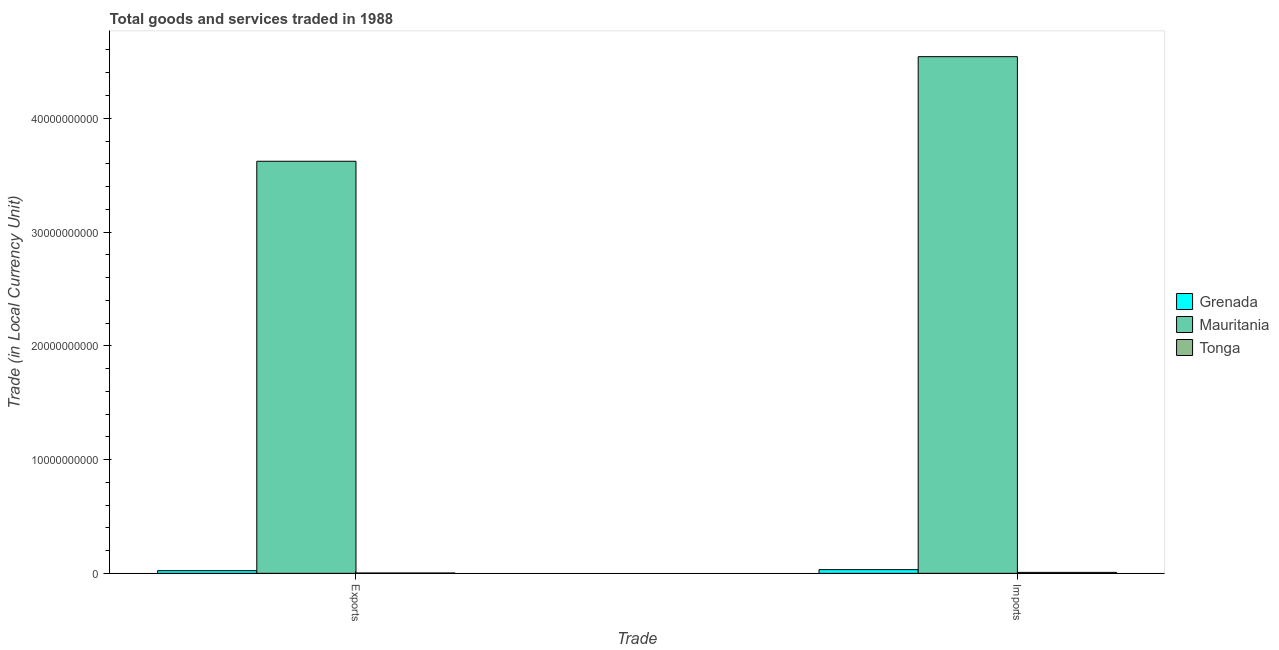How many bars are there on the 1st tick from the left?
Keep it short and to the point. 3. What is the label of the 2nd group of bars from the left?
Ensure brevity in your answer.  Imports. What is the export of goods and services in Tonga?
Offer a very short reply. 2.84e+07. Across all countries, what is the maximum imports of goods and services?
Your answer should be very brief. 4.54e+1. Across all countries, what is the minimum export of goods and services?
Ensure brevity in your answer.  2.84e+07. In which country was the export of goods and services maximum?
Provide a short and direct response. Mauritania. In which country was the imports of goods and services minimum?
Provide a succinct answer. Tonga. What is the total imports of goods and services in the graph?
Keep it short and to the point. 4.58e+1. What is the difference between the export of goods and services in Mauritania and that in Grenada?
Offer a very short reply. 3.60e+1. What is the difference between the imports of goods and services in Tonga and the export of goods and services in Grenada?
Provide a succinct answer. -1.51e+08. What is the average imports of goods and services per country?
Your response must be concise. 1.53e+1. What is the difference between the export of goods and services and imports of goods and services in Mauritania?
Make the answer very short. -9.19e+09. What is the ratio of the imports of goods and services in Tonga to that in Grenada?
Provide a short and direct response. 0.26. Is the export of goods and services in Tonga less than that in Grenada?
Offer a terse response. Yes. In how many countries, is the export of goods and services greater than the average export of goods and services taken over all countries?
Your response must be concise. 1. What does the 3rd bar from the left in Imports represents?
Provide a short and direct response. Tonga. What does the 2nd bar from the right in Imports represents?
Provide a succinct answer. Mauritania. Are all the bars in the graph horizontal?
Make the answer very short. No. How many countries are there in the graph?
Your answer should be compact. 3. Does the graph contain grids?
Make the answer very short. No. Where does the legend appear in the graph?
Make the answer very short. Center right. How many legend labels are there?
Your response must be concise. 3. What is the title of the graph?
Offer a terse response. Total goods and services traded in 1988. What is the label or title of the X-axis?
Provide a succinct answer. Trade. What is the label or title of the Y-axis?
Offer a terse response. Trade (in Local Currency Unit). What is the Trade (in Local Currency Unit) in Grenada in Exports?
Offer a very short reply. 2.34e+08. What is the Trade (in Local Currency Unit) of Mauritania in Exports?
Provide a succinct answer. 3.62e+1. What is the Trade (in Local Currency Unit) in Tonga in Exports?
Provide a succinct answer. 2.84e+07. What is the Trade (in Local Currency Unit) of Grenada in Imports?
Give a very brief answer. 3.24e+08. What is the Trade (in Local Currency Unit) of Mauritania in Imports?
Offer a terse response. 4.54e+1. What is the Trade (in Local Currency Unit) of Tonga in Imports?
Ensure brevity in your answer.  8.33e+07. Across all Trade, what is the maximum Trade (in Local Currency Unit) of Grenada?
Provide a short and direct response. 3.24e+08. Across all Trade, what is the maximum Trade (in Local Currency Unit) of Mauritania?
Offer a terse response. 4.54e+1. Across all Trade, what is the maximum Trade (in Local Currency Unit) in Tonga?
Your answer should be compact. 8.33e+07. Across all Trade, what is the minimum Trade (in Local Currency Unit) in Grenada?
Your answer should be very brief. 2.34e+08. Across all Trade, what is the minimum Trade (in Local Currency Unit) in Mauritania?
Provide a succinct answer. 3.62e+1. Across all Trade, what is the minimum Trade (in Local Currency Unit) of Tonga?
Your answer should be very brief. 2.84e+07. What is the total Trade (in Local Currency Unit) in Grenada in the graph?
Offer a terse response. 5.58e+08. What is the total Trade (in Local Currency Unit) in Mauritania in the graph?
Your response must be concise. 8.16e+1. What is the total Trade (in Local Currency Unit) of Tonga in the graph?
Your answer should be compact. 1.12e+08. What is the difference between the Trade (in Local Currency Unit) in Grenada in Exports and that in Imports?
Give a very brief answer. -8.93e+07. What is the difference between the Trade (in Local Currency Unit) in Mauritania in Exports and that in Imports?
Your answer should be very brief. -9.19e+09. What is the difference between the Trade (in Local Currency Unit) in Tonga in Exports and that in Imports?
Give a very brief answer. -5.49e+07. What is the difference between the Trade (in Local Currency Unit) in Grenada in Exports and the Trade (in Local Currency Unit) in Mauritania in Imports?
Your answer should be very brief. -4.52e+1. What is the difference between the Trade (in Local Currency Unit) of Grenada in Exports and the Trade (in Local Currency Unit) of Tonga in Imports?
Provide a short and direct response. 1.51e+08. What is the difference between the Trade (in Local Currency Unit) of Mauritania in Exports and the Trade (in Local Currency Unit) of Tonga in Imports?
Your answer should be very brief. 3.61e+1. What is the average Trade (in Local Currency Unit) in Grenada per Trade?
Provide a succinct answer. 2.79e+08. What is the average Trade (in Local Currency Unit) of Mauritania per Trade?
Ensure brevity in your answer.  4.08e+1. What is the average Trade (in Local Currency Unit) of Tonga per Trade?
Your response must be concise. 5.58e+07. What is the difference between the Trade (in Local Currency Unit) in Grenada and Trade (in Local Currency Unit) in Mauritania in Exports?
Make the answer very short. -3.60e+1. What is the difference between the Trade (in Local Currency Unit) in Grenada and Trade (in Local Currency Unit) in Tonga in Exports?
Offer a terse response. 2.06e+08. What is the difference between the Trade (in Local Currency Unit) in Mauritania and Trade (in Local Currency Unit) in Tonga in Exports?
Provide a succinct answer. 3.62e+1. What is the difference between the Trade (in Local Currency Unit) in Grenada and Trade (in Local Currency Unit) in Mauritania in Imports?
Provide a succinct answer. -4.51e+1. What is the difference between the Trade (in Local Currency Unit) of Grenada and Trade (in Local Currency Unit) of Tonga in Imports?
Ensure brevity in your answer.  2.40e+08. What is the difference between the Trade (in Local Currency Unit) of Mauritania and Trade (in Local Currency Unit) of Tonga in Imports?
Offer a terse response. 4.53e+1. What is the ratio of the Trade (in Local Currency Unit) of Grenada in Exports to that in Imports?
Your response must be concise. 0.72. What is the ratio of the Trade (in Local Currency Unit) of Mauritania in Exports to that in Imports?
Your answer should be compact. 0.8. What is the ratio of the Trade (in Local Currency Unit) of Tonga in Exports to that in Imports?
Your answer should be compact. 0.34. What is the difference between the highest and the second highest Trade (in Local Currency Unit) in Grenada?
Ensure brevity in your answer.  8.93e+07. What is the difference between the highest and the second highest Trade (in Local Currency Unit) of Mauritania?
Offer a very short reply. 9.19e+09. What is the difference between the highest and the second highest Trade (in Local Currency Unit) in Tonga?
Keep it short and to the point. 5.49e+07. What is the difference between the highest and the lowest Trade (in Local Currency Unit) of Grenada?
Keep it short and to the point. 8.93e+07. What is the difference between the highest and the lowest Trade (in Local Currency Unit) in Mauritania?
Make the answer very short. 9.19e+09. What is the difference between the highest and the lowest Trade (in Local Currency Unit) in Tonga?
Ensure brevity in your answer.  5.49e+07. 